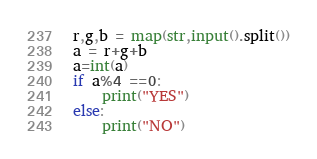Convert code to text. <code><loc_0><loc_0><loc_500><loc_500><_Python_>r,g,b = map(str,input().split())
a = r+g+b
a=int(a)
if a%4 ==0:
    print("YES")
else:
    print("NO")
</code> 